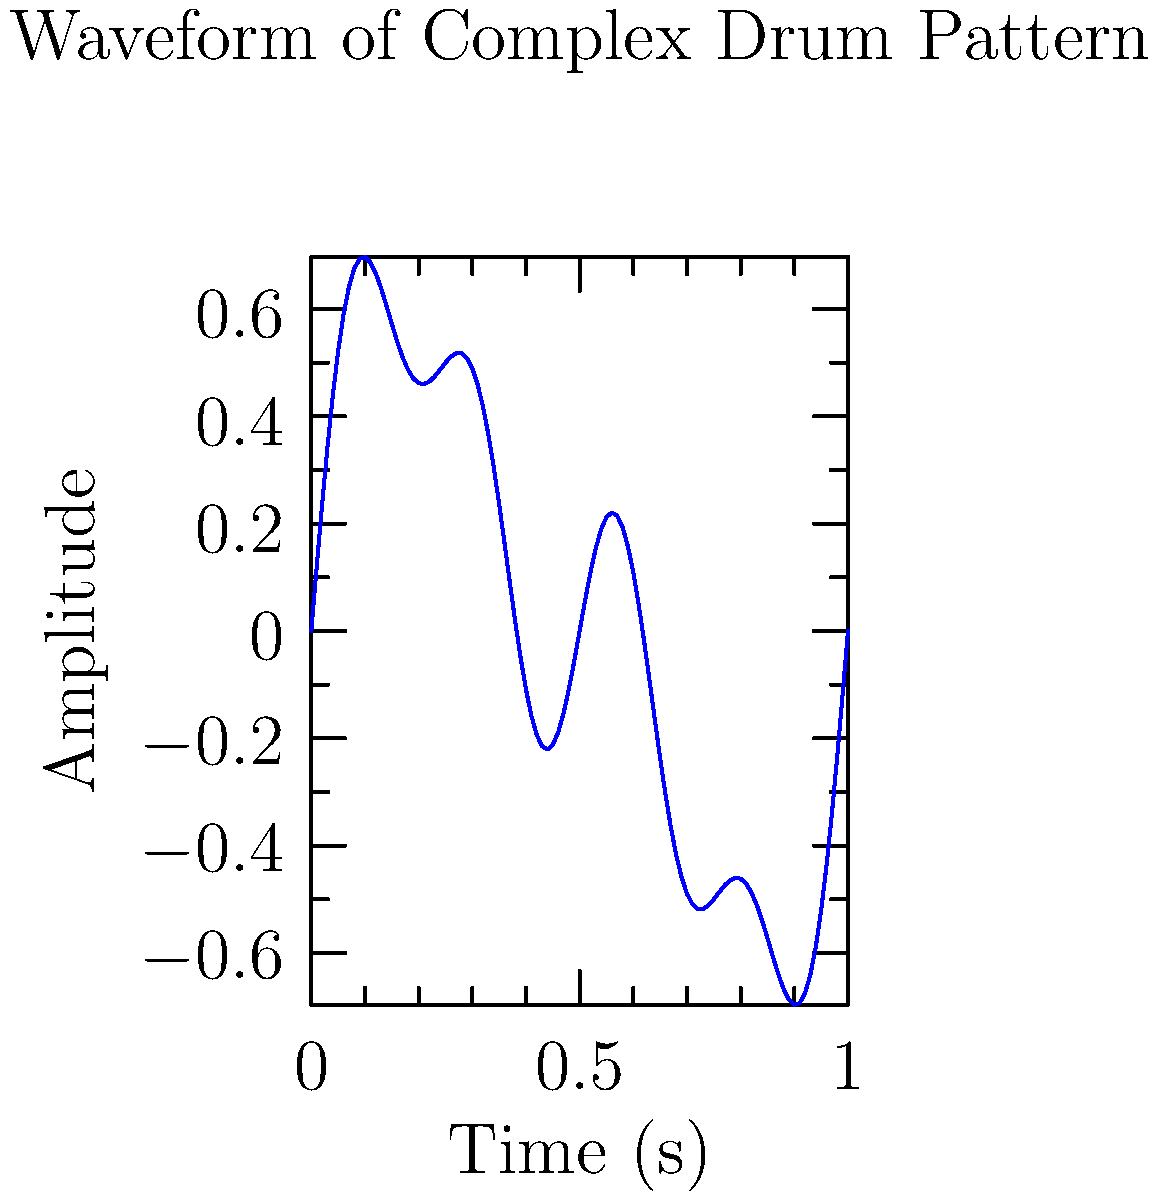Analyze the waveform of this complex drum pattern. What is the fundamental frequency of the pattern, given that the graph represents a 1-second duration? To determine the fundamental frequency of this complex drum pattern, we need to follow these steps:

1. Observe that the waveform is a combination of multiple sine waves with different frequencies.

2. The fundamental frequency is the lowest frequency component in the complex waveform.

3. Count the number of complete cycles of the lowest frequency component within the 1-second duration.

4. In this waveform, we can see that the lowest frequency component (the one with the largest period) completes 1 full cycle in 1 second.

5. The frequency is the inverse of the period. Since there is 1 cycle per second, the fundamental frequency is:

   $f = \frac{1}{T} = \frac{1}{1\text{ s}} = 1\text{ Hz}$

6. Therefore, the fundamental frequency of this complex drum pattern is 1 Hz.

This analysis aligns with a composer's understanding of rhythm and frequency, relating to the innovative drum patterns that inspire your compositions.
Answer: 1 Hz 